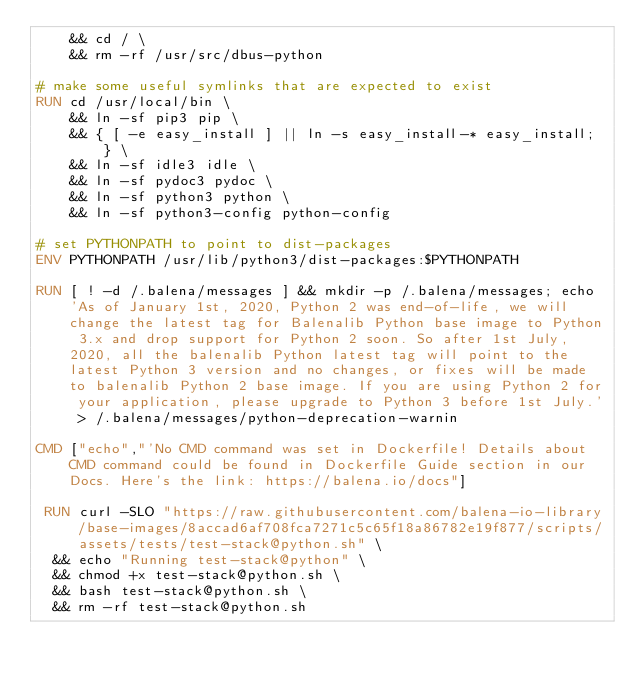<code> <loc_0><loc_0><loc_500><loc_500><_Dockerfile_>	&& cd / \
	&& rm -rf /usr/src/dbus-python

# make some useful symlinks that are expected to exist
RUN cd /usr/local/bin \
	&& ln -sf pip3 pip \
	&& { [ -e easy_install ] || ln -s easy_install-* easy_install; } \
	&& ln -sf idle3 idle \
	&& ln -sf pydoc3 pydoc \
	&& ln -sf python3 python \
	&& ln -sf python3-config python-config

# set PYTHONPATH to point to dist-packages
ENV PYTHONPATH /usr/lib/python3/dist-packages:$PYTHONPATH

RUN [ ! -d /.balena/messages ] && mkdir -p /.balena/messages; echo 'As of January 1st, 2020, Python 2 was end-of-life, we will change the latest tag for Balenalib Python base image to Python 3.x and drop support for Python 2 soon. So after 1st July, 2020, all the balenalib Python latest tag will point to the latest Python 3 version and no changes, or fixes will be made to balenalib Python 2 base image. If you are using Python 2 for your application, please upgrade to Python 3 before 1st July.' > /.balena/messages/python-deprecation-warnin

CMD ["echo","'No CMD command was set in Dockerfile! Details about CMD command could be found in Dockerfile Guide section in our Docs. Here's the link: https://balena.io/docs"]

 RUN curl -SLO "https://raw.githubusercontent.com/balena-io-library/base-images/8accad6af708fca7271c5c65f18a86782e19f877/scripts/assets/tests/test-stack@python.sh" \
  && echo "Running test-stack@python" \
  && chmod +x test-stack@python.sh \
  && bash test-stack@python.sh \
  && rm -rf test-stack@python.sh 
</code> 